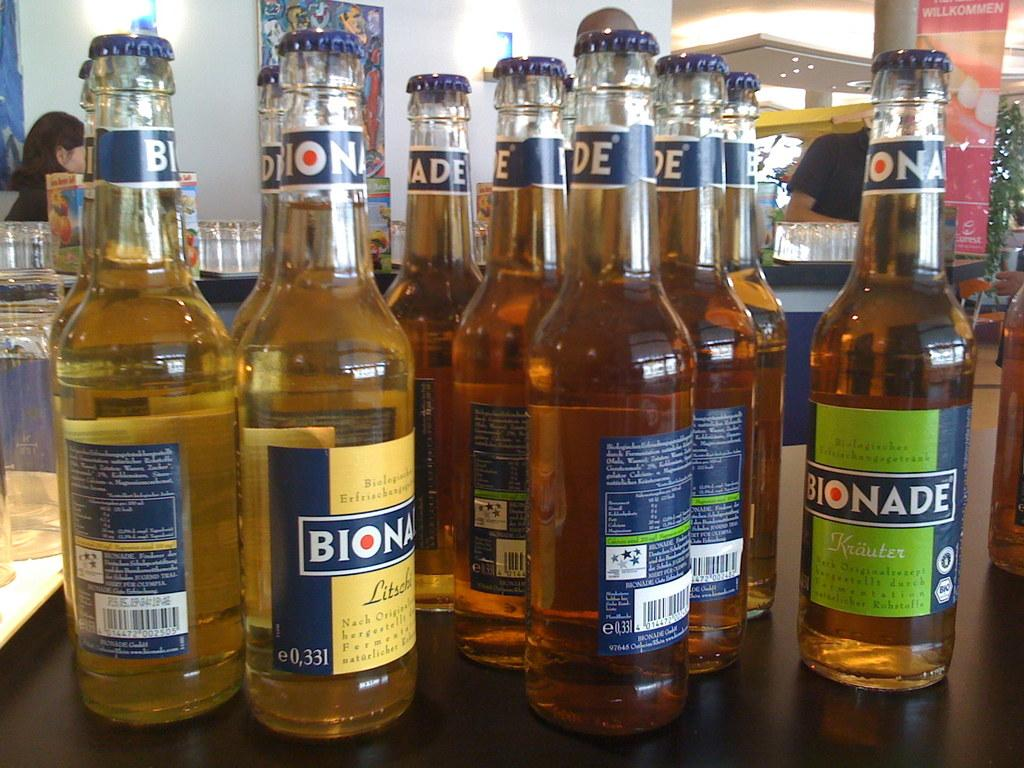<image>
Summarize the visual content of the image. A collection of Bionade beer bottle on a table top. 